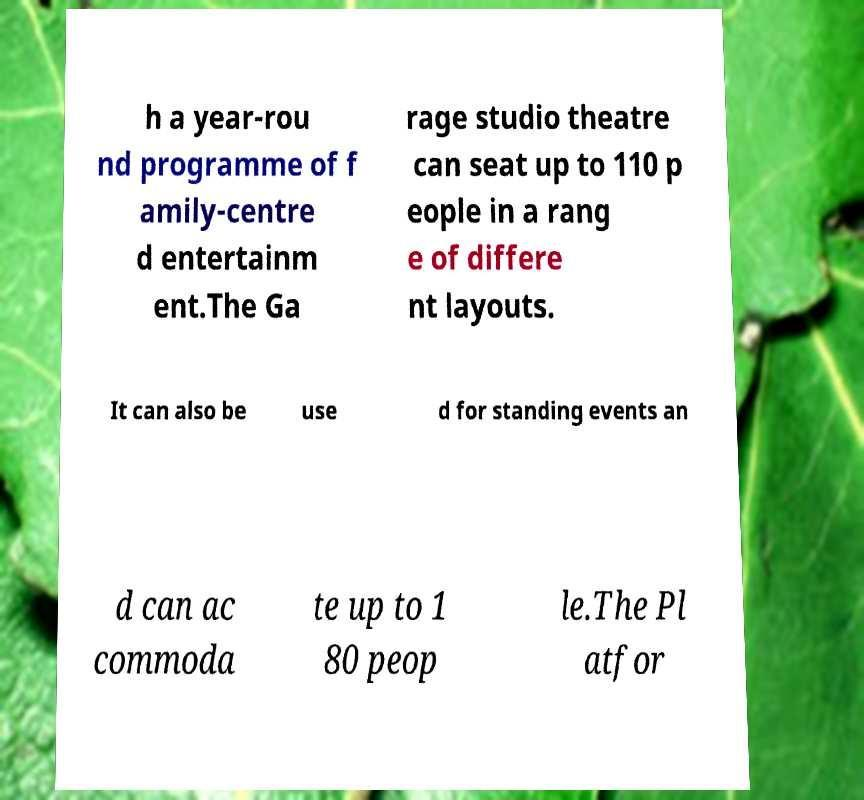Can you accurately transcribe the text from the provided image for me? h a year-rou nd programme of f amily-centre d entertainm ent.The Ga rage studio theatre can seat up to 110 p eople in a rang e of differe nt layouts. It can also be use d for standing events an d can ac commoda te up to 1 80 peop le.The Pl atfor 